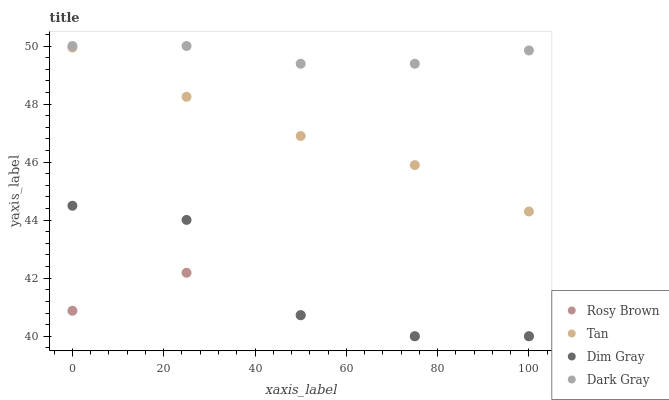Does Rosy Brown have the minimum area under the curve?
Answer yes or no. Yes. Does Dark Gray have the maximum area under the curve?
Answer yes or no. Yes. Does Tan have the minimum area under the curve?
Answer yes or no. No. Does Tan have the maximum area under the curve?
Answer yes or no. No. Is Tan the smoothest?
Answer yes or no. Yes. Is Dim Gray the roughest?
Answer yes or no. Yes. Is Rosy Brown the smoothest?
Answer yes or no. No. Is Rosy Brown the roughest?
Answer yes or no. No. Does Rosy Brown have the lowest value?
Answer yes or no. Yes. Does Tan have the lowest value?
Answer yes or no. No. Does Dark Gray have the highest value?
Answer yes or no. Yes. Does Tan have the highest value?
Answer yes or no. No. Is Tan less than Dark Gray?
Answer yes or no. Yes. Is Tan greater than Rosy Brown?
Answer yes or no. Yes. Does Dim Gray intersect Rosy Brown?
Answer yes or no. Yes. Is Dim Gray less than Rosy Brown?
Answer yes or no. No. Is Dim Gray greater than Rosy Brown?
Answer yes or no. No. Does Tan intersect Dark Gray?
Answer yes or no. No. 